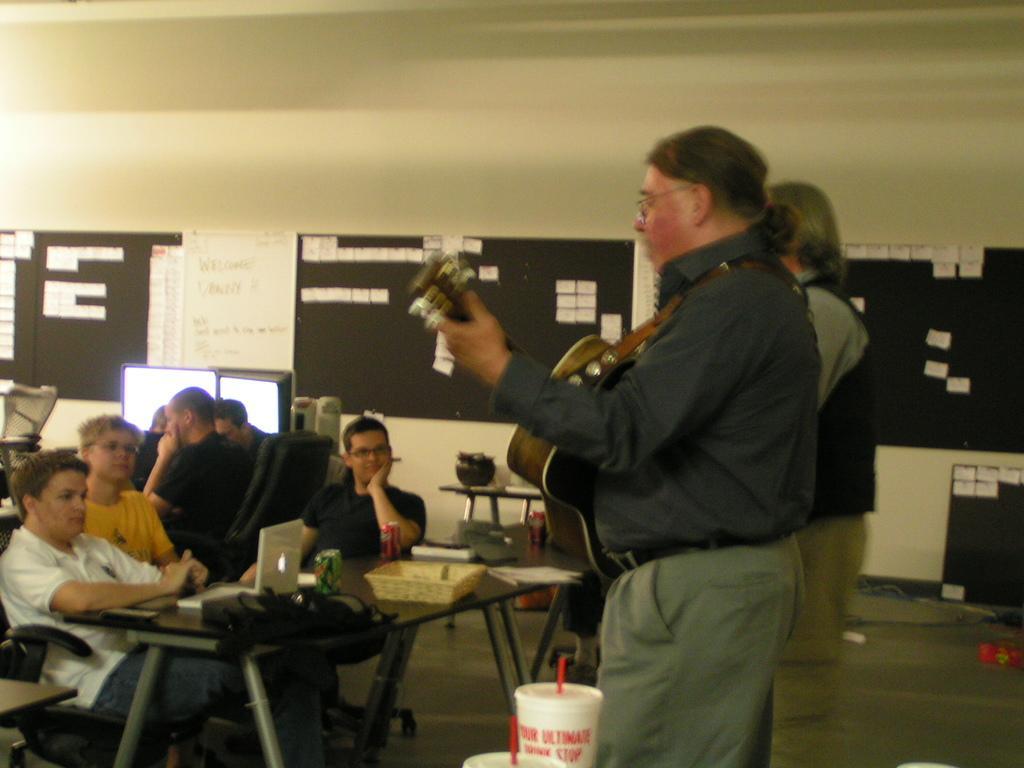In one or two sentences, can you explain what this image depicts? Few people sitting on chairs and these people are standing and this person holding a guitar. We can see laptop,bag,papers and objects on the table. In the background we can see papers on board,wall and objects. 